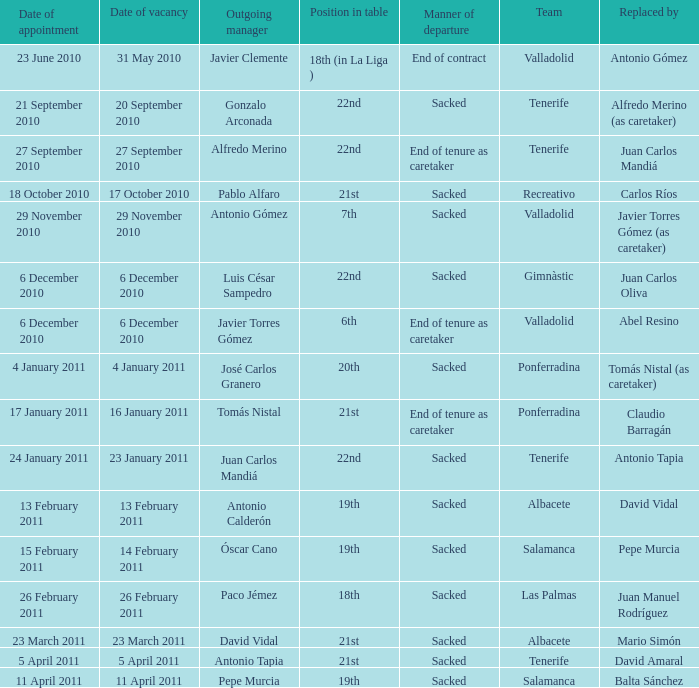What was the position of appointment date 17 january 2011 21st. 